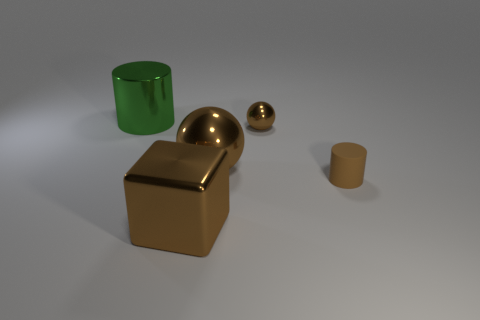Add 3 brown shiny blocks. How many objects exist? 8 Subtract all cylinders. How many objects are left? 3 Subtract all brown cylinders. How many cylinders are left? 1 Subtract 1 brown balls. How many objects are left? 4 Subtract 1 cylinders. How many cylinders are left? 1 Subtract all yellow cubes. Subtract all green cylinders. How many cubes are left? 1 Subtract all large blue matte balls. Subtract all green things. How many objects are left? 4 Add 3 brown cylinders. How many brown cylinders are left? 4 Add 5 metal cylinders. How many metal cylinders exist? 6 